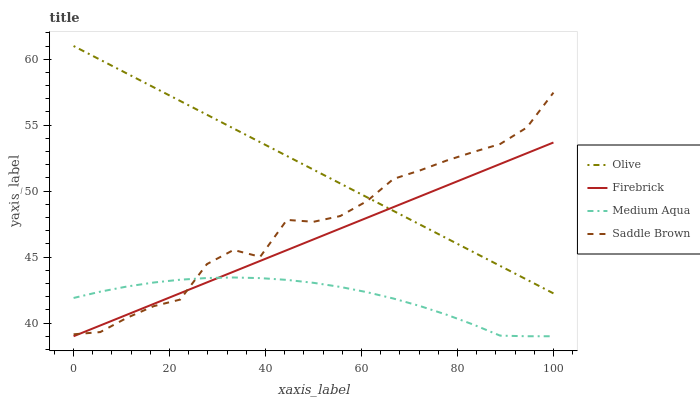Does Medium Aqua have the minimum area under the curve?
Answer yes or no. Yes. Does Olive have the maximum area under the curve?
Answer yes or no. Yes. Does Firebrick have the minimum area under the curve?
Answer yes or no. No. Does Firebrick have the maximum area under the curve?
Answer yes or no. No. Is Olive the smoothest?
Answer yes or no. Yes. Is Saddle Brown the roughest?
Answer yes or no. Yes. Is Firebrick the smoothest?
Answer yes or no. No. Is Firebrick the roughest?
Answer yes or no. No. Does Saddle Brown have the lowest value?
Answer yes or no. No. Does Olive have the highest value?
Answer yes or no. Yes. Does Firebrick have the highest value?
Answer yes or no. No. Is Medium Aqua less than Olive?
Answer yes or no. Yes. Is Olive greater than Medium Aqua?
Answer yes or no. Yes. Does Firebrick intersect Olive?
Answer yes or no. Yes. Is Firebrick less than Olive?
Answer yes or no. No. Is Firebrick greater than Olive?
Answer yes or no. No. Does Medium Aqua intersect Olive?
Answer yes or no. No. 